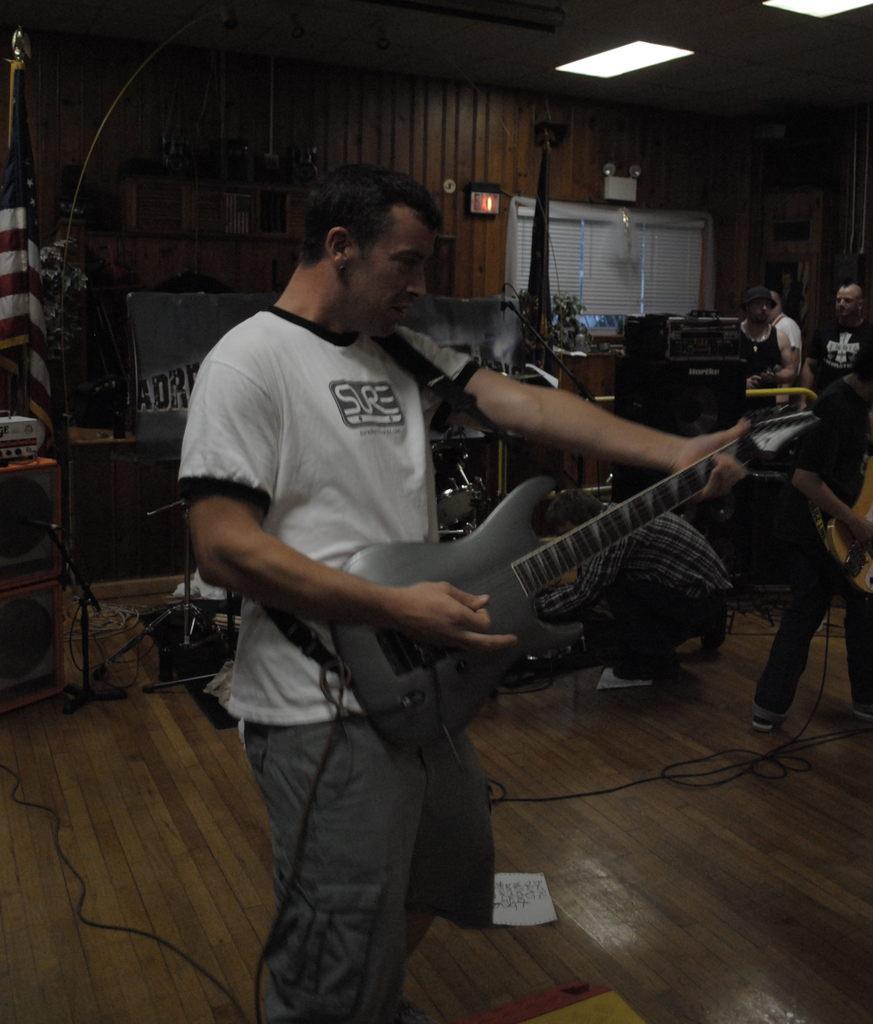How would you summarize this image in a sentence or two? This is a picture of a band performing. In the center of the picture there is a man standing and playing guitar. On the top left this is a desk and a flag and a plant. On the right there is a person standing and playing guitar. In the center there is a person adjusting cables. On the top right there person sitting adjusting music. In the top right there is a wall and a window. On the top selling and light in there are cables and paper. 